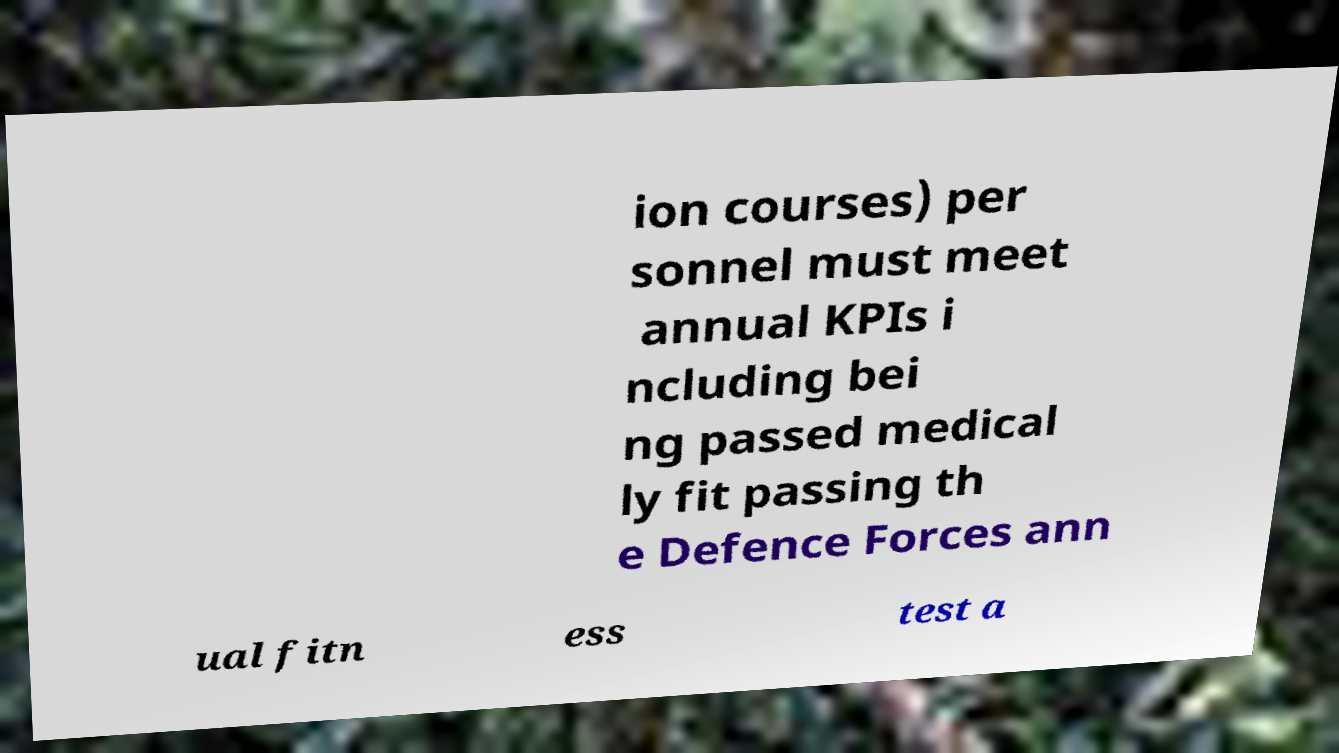Please identify and transcribe the text found in this image. ion courses) per sonnel must meet annual KPIs i ncluding bei ng passed medical ly fit passing th e Defence Forces ann ual fitn ess test a 